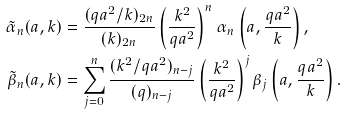Convert formula to latex. <formula><loc_0><loc_0><loc_500><loc_500>\tilde { \alpha } _ { n } ( a , k ) & = \frac { ( q a ^ { 2 } / k ) _ { 2 n } } { ( k ) _ { 2 n } } \left ( \frac { k ^ { 2 } } { q a ^ { 2 } } \right ) ^ { n } \alpha _ { n } \left ( a , \frac { q a ^ { 2 } } { k } \right ) , \\ \tilde { \beta } _ { n } ( a , k ) & = \sum _ { j = 0 } ^ { n } \frac { ( k ^ { 2 } / q a ^ { 2 } ) _ { n - j } } { ( q ) _ { n - j } } \left ( \frac { k ^ { 2 } } { q a ^ { 2 } } \right ) ^ { j } \beta _ { j } \left ( a , \frac { q a ^ { 2 } } { k } \right ) .</formula> 